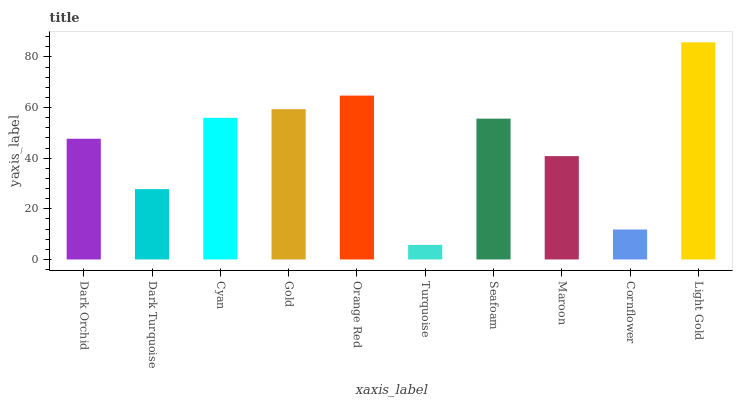Is Turquoise the minimum?
Answer yes or no. Yes. Is Light Gold the maximum?
Answer yes or no. Yes. Is Dark Turquoise the minimum?
Answer yes or no. No. Is Dark Turquoise the maximum?
Answer yes or no. No. Is Dark Orchid greater than Dark Turquoise?
Answer yes or no. Yes. Is Dark Turquoise less than Dark Orchid?
Answer yes or no. Yes. Is Dark Turquoise greater than Dark Orchid?
Answer yes or no. No. Is Dark Orchid less than Dark Turquoise?
Answer yes or no. No. Is Seafoam the high median?
Answer yes or no. Yes. Is Dark Orchid the low median?
Answer yes or no. Yes. Is Gold the high median?
Answer yes or no. No. Is Orange Red the low median?
Answer yes or no. No. 